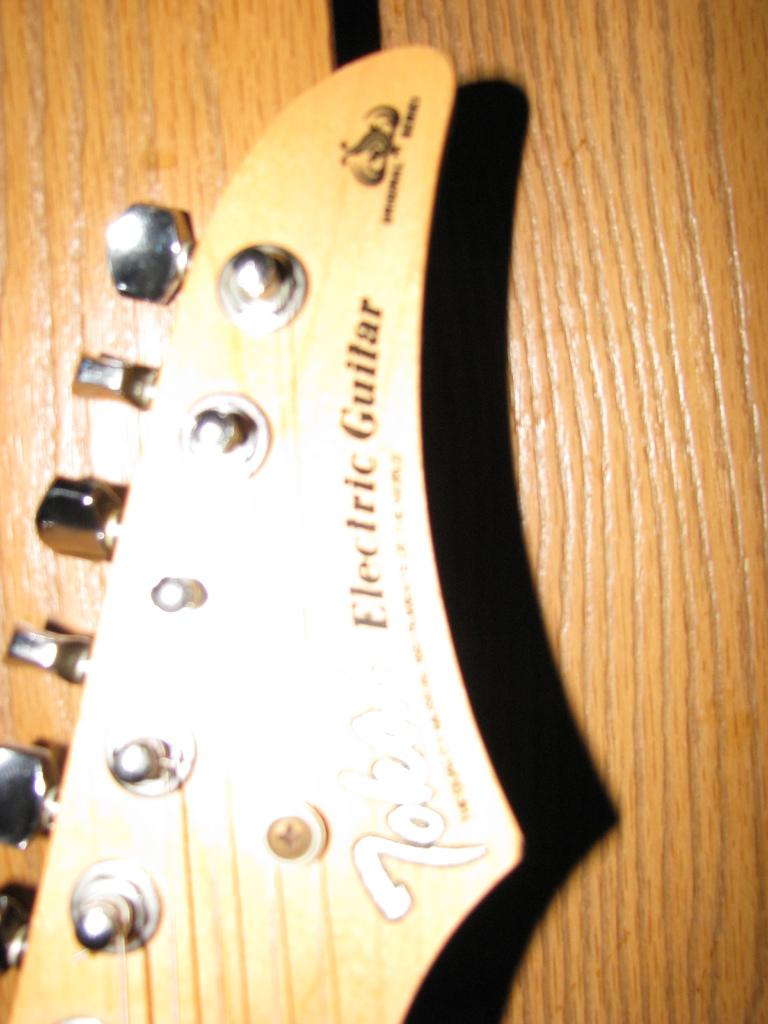What musical instrument is present in the image? There is a guitar in the image. Can you describe the guitar in more detail? Unfortunately, the image only shows the guitar, and no additional details are provided. How many deer can be seen playing the guitar in the image? There are no deer present in the image, and the guitar is not being played by any animals. 